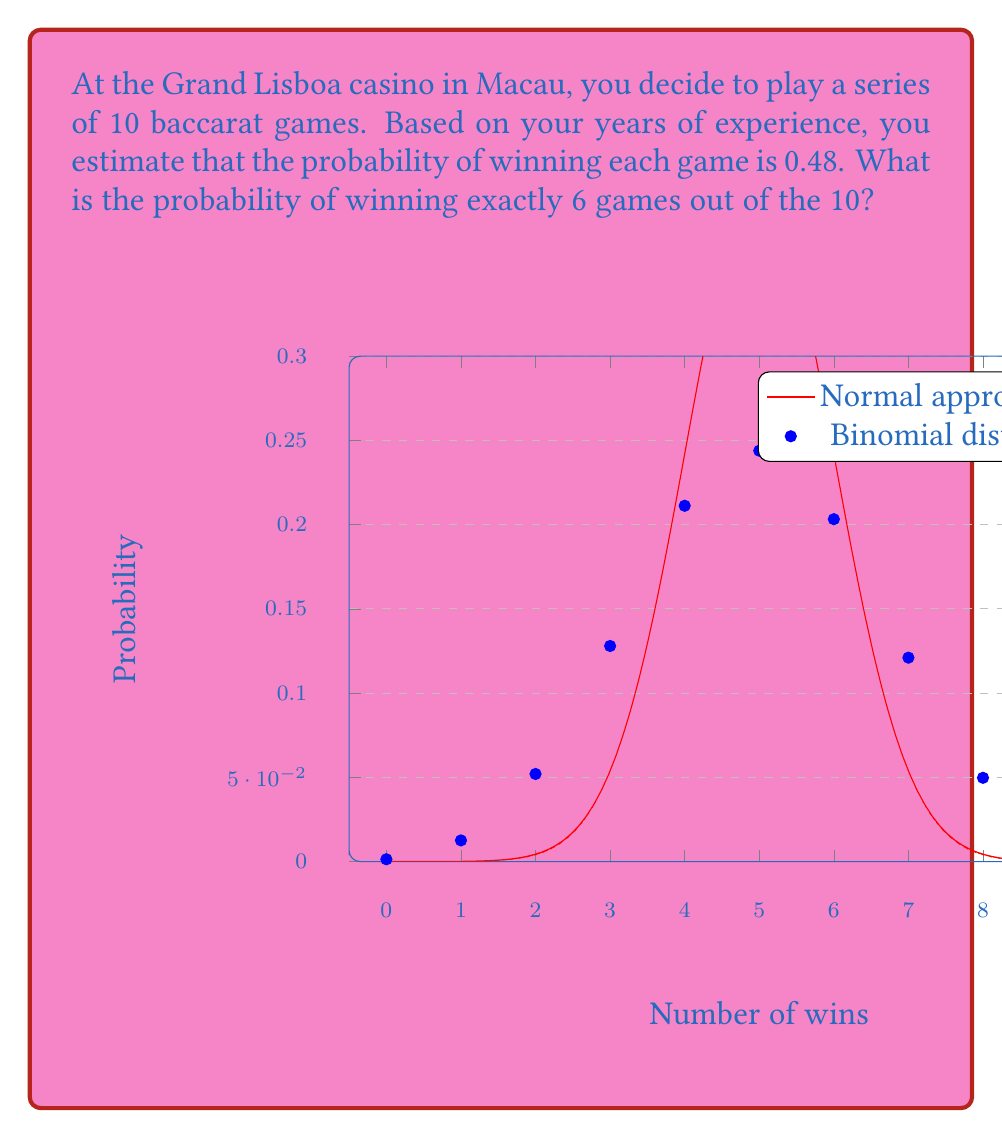Teach me how to tackle this problem. To solve this problem, we need to use the binomial distribution formula:

$$P(X=k) = \binom{n}{k} p^k (1-p)^{n-k}$$

Where:
- $n$ is the number of trials (10 games)
- $k$ is the number of successes (6 wins)
- $p$ is the probability of success on each trial (0.48)

Let's break it down step-by-step:

1) Calculate $\binom{n}{k}$:
   $$\binom{10}{6} = \frac{10!}{6!(10-6)!} = \frac{10!}{6!4!} = 210$$

2) Calculate $p^k$:
   $$0.48^6 \approx 0.0138$$

3) Calculate $(1-p)^{n-k}$:
   $$(1-0.48)^{10-6} = 0.52^4 \approx 0.0730$$

4) Multiply all parts together:
   $$210 \times 0.0138 \times 0.0730 \approx 0.2113$$

Therefore, the probability of winning exactly 6 games out of 10 is approximately 0.2113 or 21.13%.
Answer: $0.2113$ or $21.13\%$ 